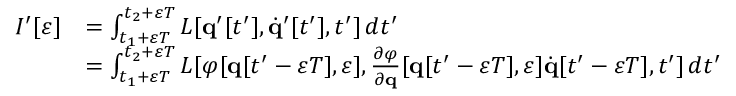<formula> <loc_0><loc_0><loc_500><loc_500>{ \begin{array} { r l } { I ^ { \prime } [ \varepsilon ] } & { = \int _ { t _ { 1 } + \varepsilon T } ^ { t _ { 2 } + \varepsilon T } L [ q ^ { \prime } [ t ^ { \prime } ] , { \dot { q } } ^ { \prime } [ t ^ { \prime } ] , t ^ { \prime } ] \, d t ^ { \prime } } \\ & { = \int _ { t _ { 1 } + \varepsilon T } ^ { t _ { 2 } + \varepsilon T } L [ \varphi [ q [ t ^ { \prime } - \varepsilon T ] , \varepsilon ] , { \frac { \partial \varphi } { \partial q } } [ q [ t ^ { \prime } - \varepsilon T ] , \varepsilon ] { \dot { q } } [ t ^ { \prime } - \varepsilon T ] , t ^ { \prime } ] \, d t ^ { \prime } } \end{array} }</formula> 